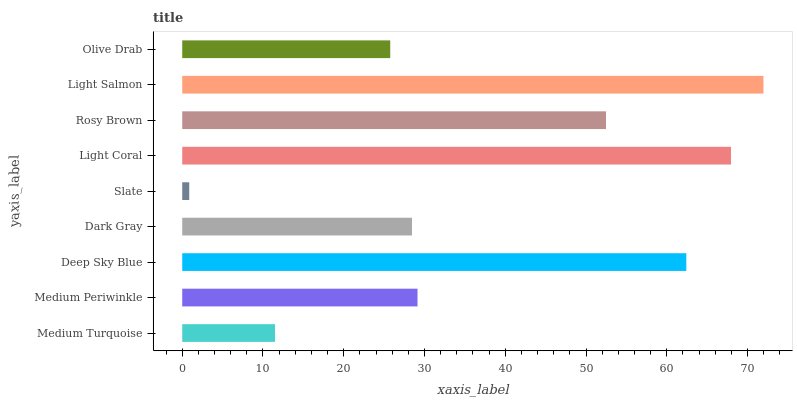Is Slate the minimum?
Answer yes or no. Yes. Is Light Salmon the maximum?
Answer yes or no. Yes. Is Medium Periwinkle the minimum?
Answer yes or no. No. Is Medium Periwinkle the maximum?
Answer yes or no. No. Is Medium Periwinkle greater than Medium Turquoise?
Answer yes or no. Yes. Is Medium Turquoise less than Medium Periwinkle?
Answer yes or no. Yes. Is Medium Turquoise greater than Medium Periwinkle?
Answer yes or no. No. Is Medium Periwinkle less than Medium Turquoise?
Answer yes or no. No. Is Medium Periwinkle the high median?
Answer yes or no. Yes. Is Medium Periwinkle the low median?
Answer yes or no. Yes. Is Light Salmon the high median?
Answer yes or no. No. Is Olive Drab the low median?
Answer yes or no. No. 